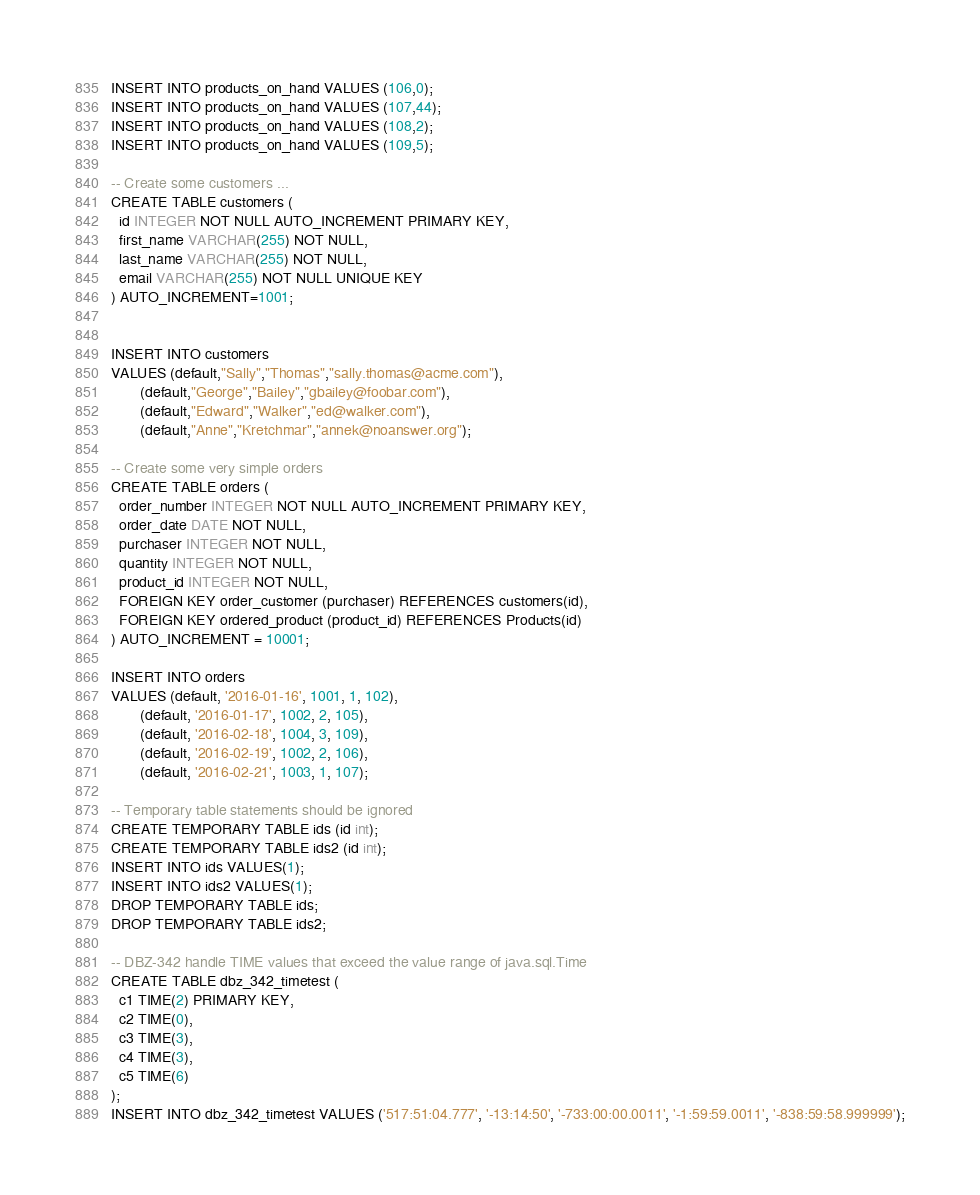<code> <loc_0><loc_0><loc_500><loc_500><_SQL_>INSERT INTO products_on_hand VALUES (106,0);
INSERT INTO products_on_hand VALUES (107,44);
INSERT INTO products_on_hand VALUES (108,2);
INSERT INTO products_on_hand VALUES (109,5);

-- Create some customers ...
CREATE TABLE customers (
  id INTEGER NOT NULL AUTO_INCREMENT PRIMARY KEY,
  first_name VARCHAR(255) NOT NULL,
  last_name VARCHAR(255) NOT NULL,
  email VARCHAR(255) NOT NULL UNIQUE KEY
) AUTO_INCREMENT=1001;


INSERT INTO customers
VALUES (default,"Sally","Thomas","sally.thomas@acme.com"),
       (default,"George","Bailey","gbailey@foobar.com"),
       (default,"Edward","Walker","ed@walker.com"),
       (default,"Anne","Kretchmar","annek@noanswer.org");

-- Create some very simple orders
CREATE TABLE orders (
  order_number INTEGER NOT NULL AUTO_INCREMENT PRIMARY KEY,
  order_date DATE NOT NULL,
  purchaser INTEGER NOT NULL,
  quantity INTEGER NOT NULL,
  product_id INTEGER NOT NULL,
  FOREIGN KEY order_customer (purchaser) REFERENCES customers(id),
  FOREIGN KEY ordered_product (product_id) REFERENCES Products(id)
) AUTO_INCREMENT = 10001;

INSERT INTO orders 
VALUES (default, '2016-01-16', 1001, 1, 102),
       (default, '2016-01-17', 1002, 2, 105),
       (default, '2016-02-18', 1004, 3, 109),
       (default, '2016-02-19', 1002, 2, 106),
       (default, '2016-02-21', 1003, 1, 107);

-- Temporary table statements should be ignored
CREATE TEMPORARY TABLE ids (id int);
CREATE TEMPORARY TABLE ids2 (id int);
INSERT INTO ids VALUES(1);
INSERT INTO ids2 VALUES(1);
DROP TEMPORARY TABLE ids;
DROP TEMPORARY TABLE ids2;

-- DBZ-342 handle TIME values that exceed the value range of java.sql.Time
CREATE TABLE dbz_342_timetest (
  c1 TIME(2) PRIMARY KEY,
  c2 TIME(0),
  c3 TIME(3),
  c4 TIME(3),
  c5 TIME(6)
);
INSERT INTO dbz_342_timetest VALUES ('517:51:04.777', '-13:14:50', '-733:00:00.0011', '-1:59:59.0011', '-838:59:58.999999');
</code> 